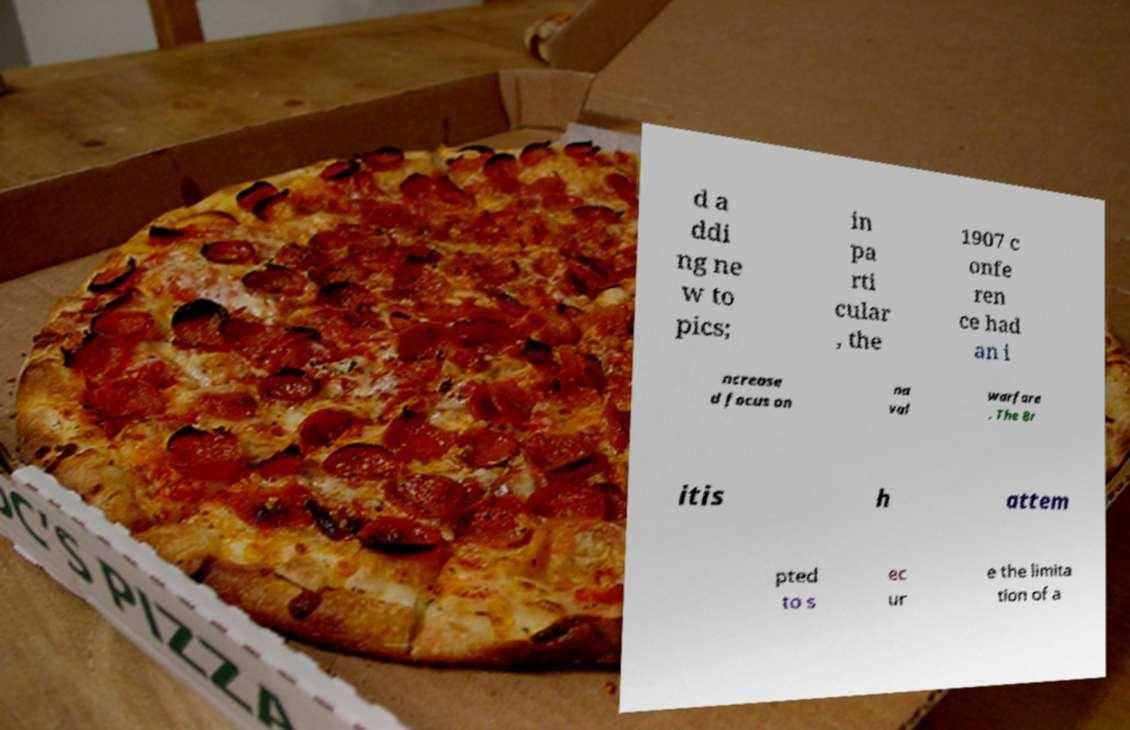Please read and relay the text visible in this image. What does it say? d a ddi ng ne w to pics; in pa rti cular , the 1907 c onfe ren ce had an i ncrease d focus on na val warfare . The Br itis h attem pted to s ec ur e the limita tion of a 